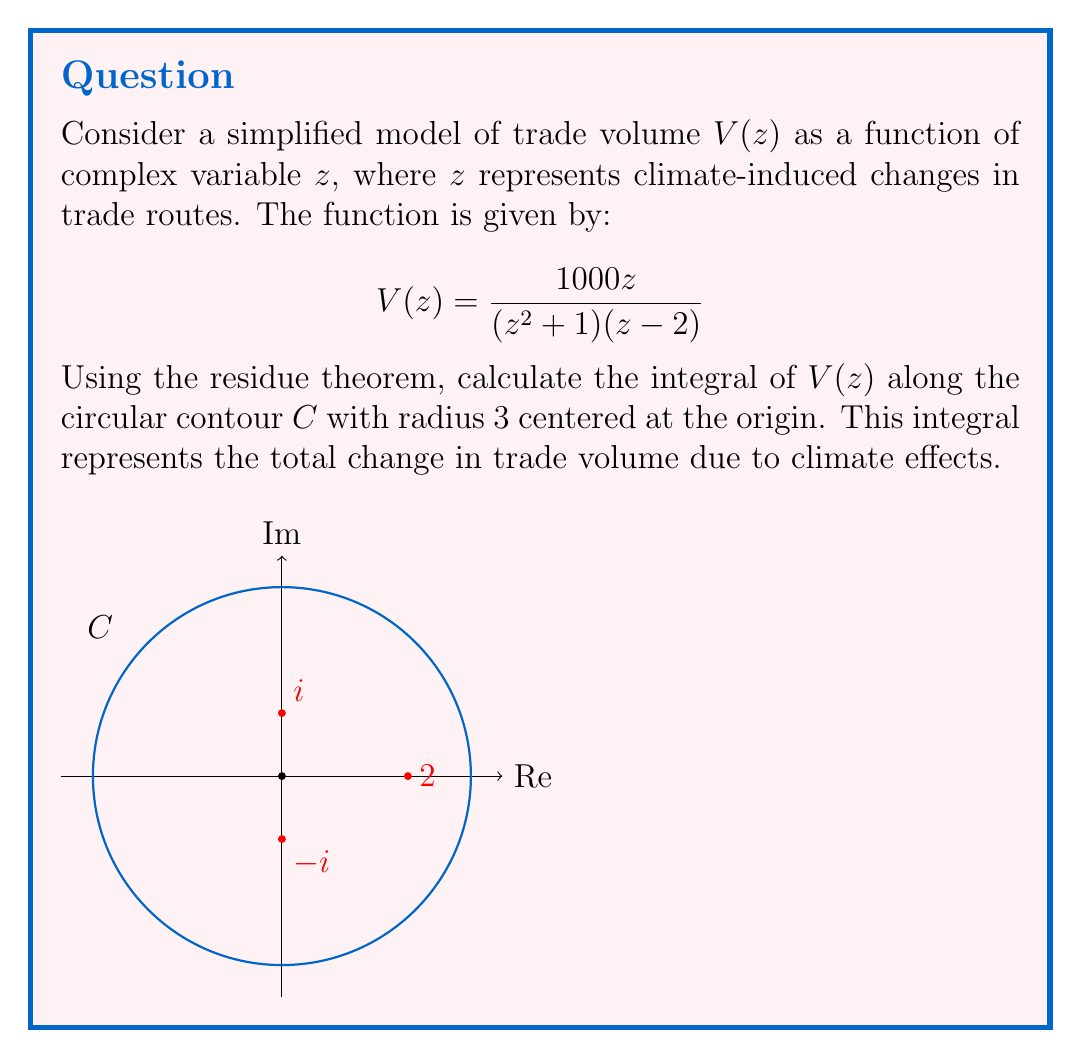Teach me how to tackle this problem. To solve this problem using the residue theorem, we follow these steps:

1) The residue theorem states that for a meromorphic function $f(z)$:

   $$\oint_C f(z)dz = 2\pi i \sum_{k=1}^n \text{Res}(f, a_k)$$

   where $a_k$ are the poles of $f(z)$ inside the contour $C$.

2) Identify the poles of $V(z)$:
   - $z = i$ (from $z^2 + 1 = 0$)
   - $z = -i$ (from $z^2 + 1 = 0$)
   - $z = 2$

3) Determine which poles are inside the contour:
   The contour has radius 3, so $i$, $-i$, and 2 are all inside.

4) Calculate the residues:

   a) For $z = i$:
      $$\text{Res}(V, i) = \lim_{z \to i} (z-i)V(z) = \frac{1000i}{2i(i-2)} = \frac{250+125i}{5}$$

   b) For $z = -i$:
      $$\text{Res}(V, -i) = \lim_{z \to -i} (z+i)V(z) = \frac{-1000i}{-2i(-i-2)} = \frac{250-125i}{5}$$

   c) For $z = 2$:
      $$\text{Res}(V, 2) = \lim_{z \to 2} (z-2)V(z) = \frac{2000}{5} = 400$$

5) Apply the residue theorem:

   $$\oint_C V(z)dz = 2\pi i \left(\frac{250+125i}{5} + \frac{250-125i}{5} + 400\right)$$

6) Simplify:
   $$\oint_C V(z)dz = 2\pi i (100 + 400) = 1000\pi i$$

This result represents the total change in trade volume due to climate effects.
Answer: $1000\pi i$ 